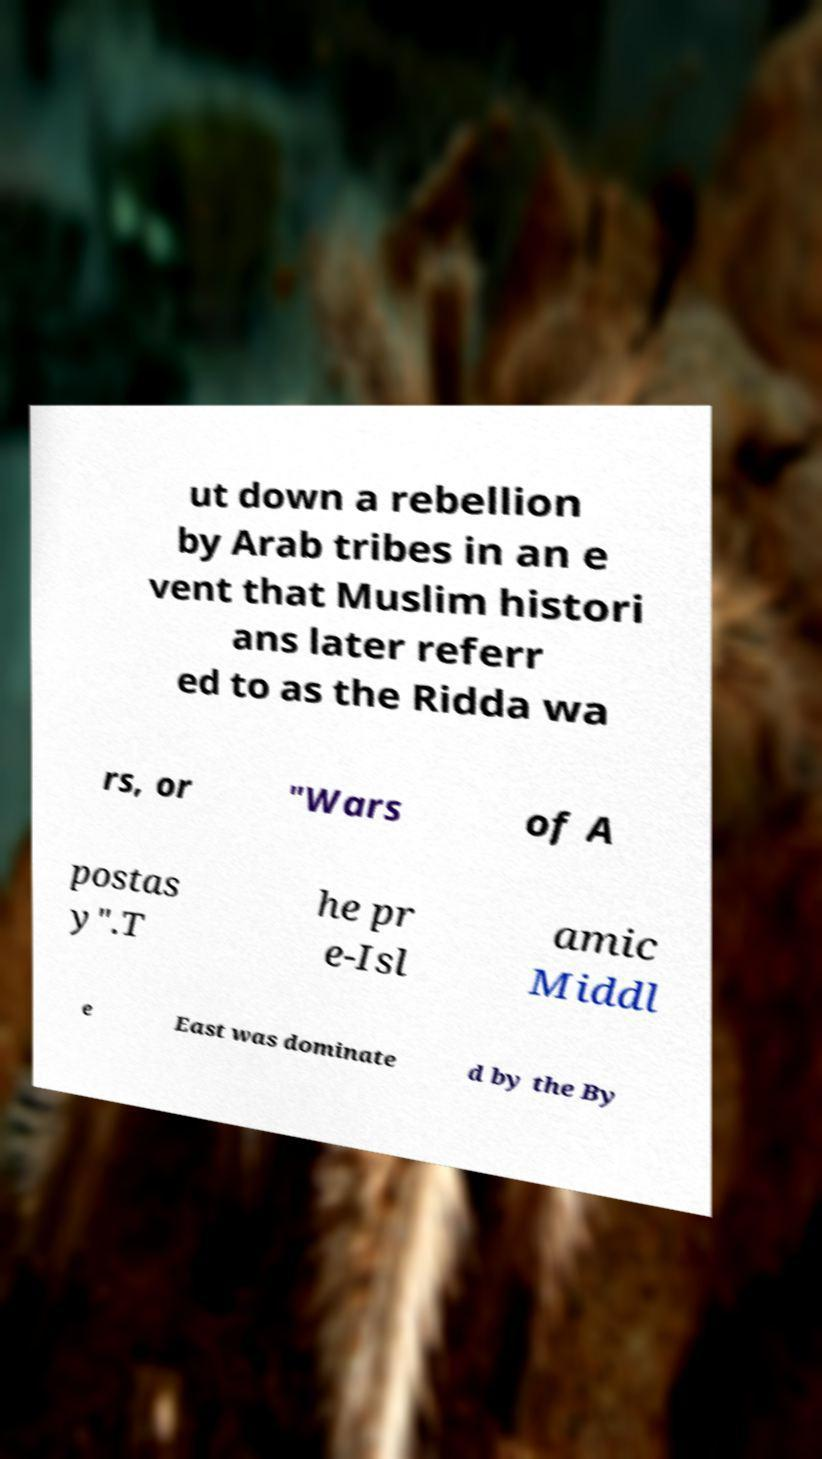Could you extract and type out the text from this image? ut down a rebellion by Arab tribes in an e vent that Muslim histori ans later referr ed to as the Ridda wa rs, or "Wars of A postas y".T he pr e-Isl amic Middl e East was dominate d by the By 